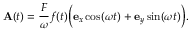<formula> <loc_0><loc_0><loc_500><loc_500>A ( t ) = \frac { F } { \omega } f ( t ) \left ( e _ { x } \cos ( \omega t ) + e _ { y } \sin ( \omega t ) \right ) .</formula> 